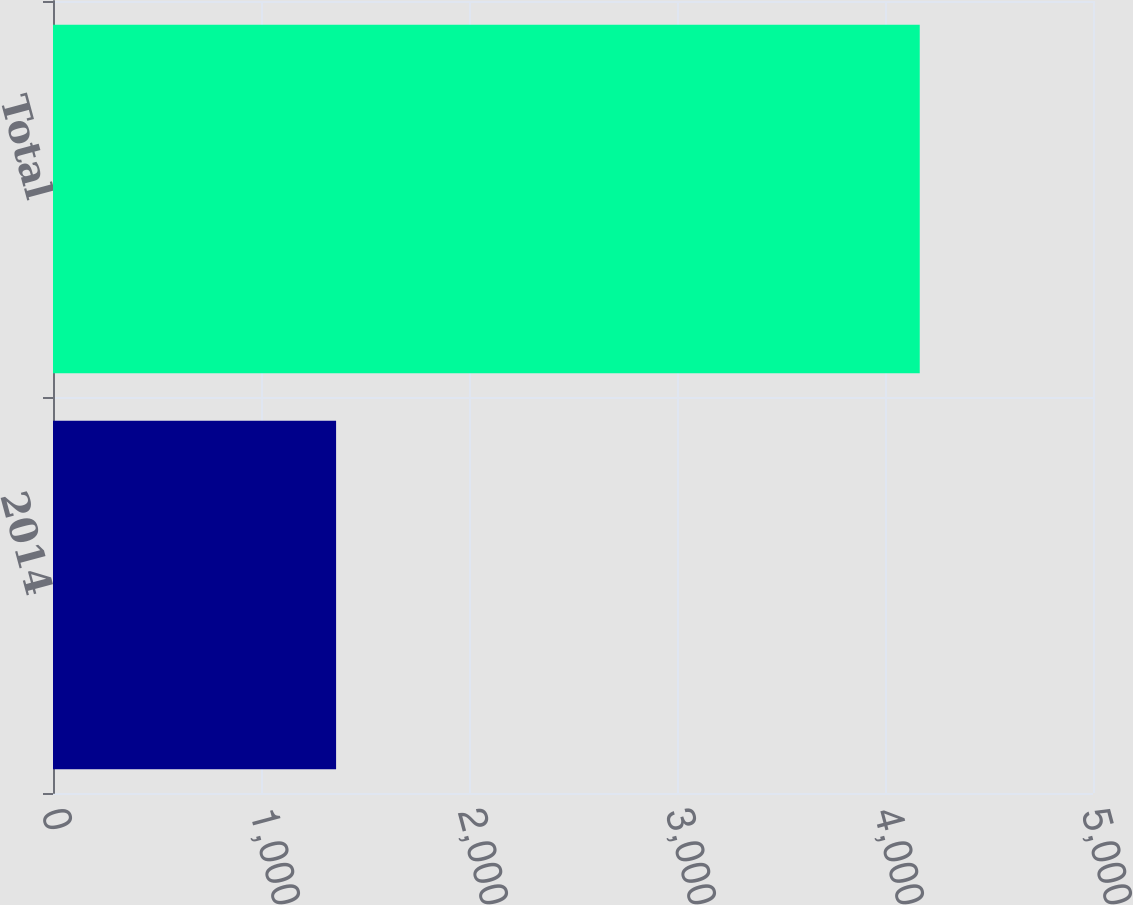<chart> <loc_0><loc_0><loc_500><loc_500><bar_chart><fcel>2014<fcel>Total<nl><fcel>1361<fcel>4167<nl></chart> 